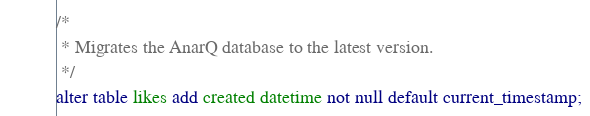<code> <loc_0><loc_0><loc_500><loc_500><_SQL_>
/*
 * Migrates the AnarQ database to the latest version.
 */
alter table likes add created datetime not null default current_timestamp;
</code> 